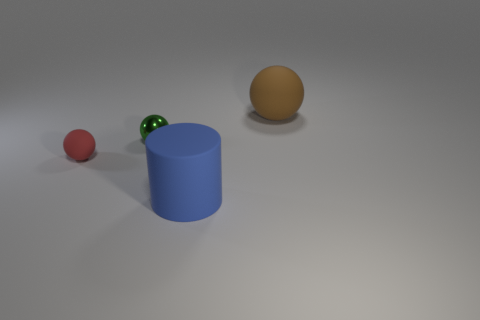What material do the objects in the image look like they're made of? The small red ball seems to be made of rubber, the pair of green objects appear to be small glass marbles, and the larger sphere looks like it could be a plastic ball. Lastly, the cylinder seems to have a matte finish indicating it might be made of plastic or metal. Which of the objects casts the longest shadow? The cylinder casts the longest shadow, indicating that it is taller than the other objects in relation to the light source. 